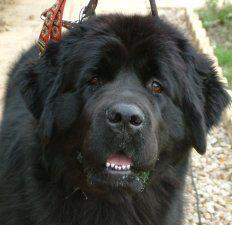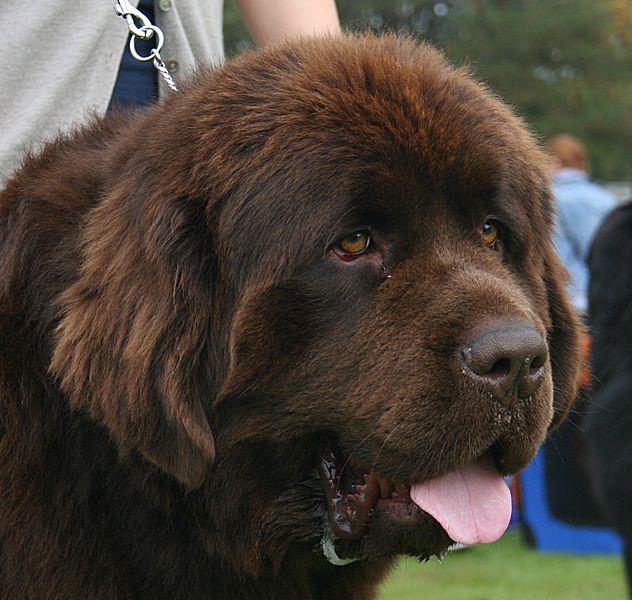The first image is the image on the left, the second image is the image on the right. Examine the images to the left and right. Is the description "Christmas decorations can be seen in one of the pictures." accurate? Answer yes or no. No. The first image is the image on the left, the second image is the image on the right. Assess this claim about the two images: "Santa-themed red and white attire is included in one image with at least one dog.". Correct or not? Answer yes or no. No. 